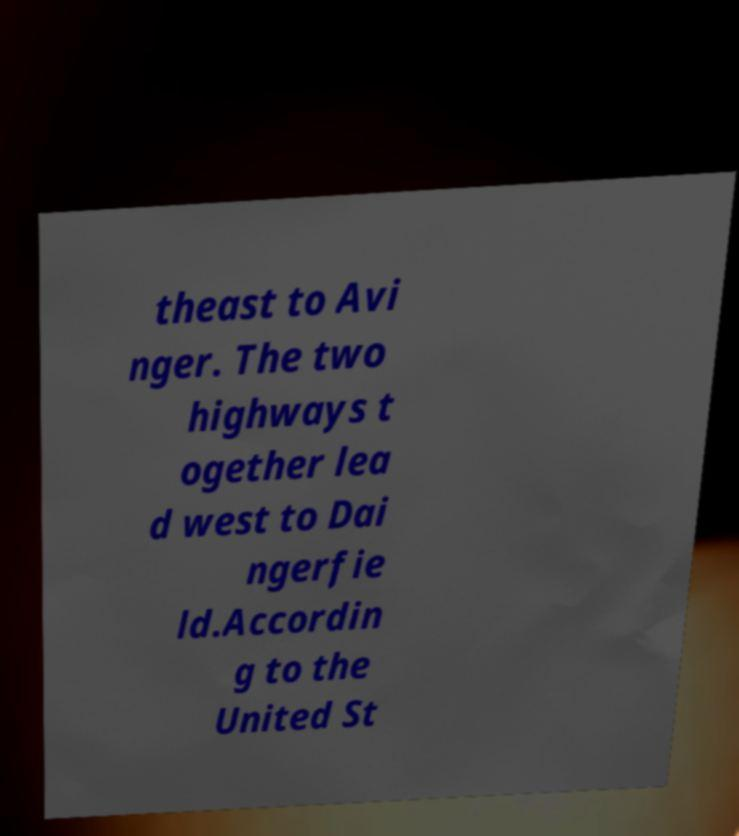There's text embedded in this image that I need extracted. Can you transcribe it verbatim? theast to Avi nger. The two highways t ogether lea d west to Dai ngerfie ld.Accordin g to the United St 